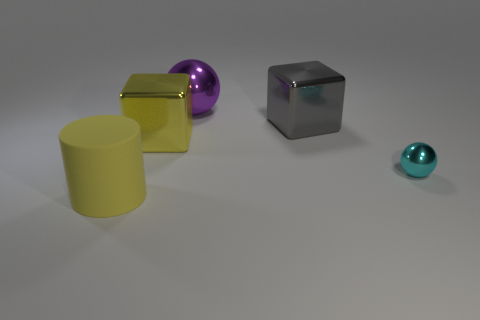Add 4 blue matte blocks. How many objects exist? 9 Subtract all blocks. How many objects are left? 3 Add 4 purple spheres. How many purple spheres are left? 5 Add 4 large yellow metal cylinders. How many large yellow metal cylinders exist? 4 Subtract 1 cyan spheres. How many objects are left? 4 Subtract all big metallic spheres. Subtract all tiny blue cylinders. How many objects are left? 4 